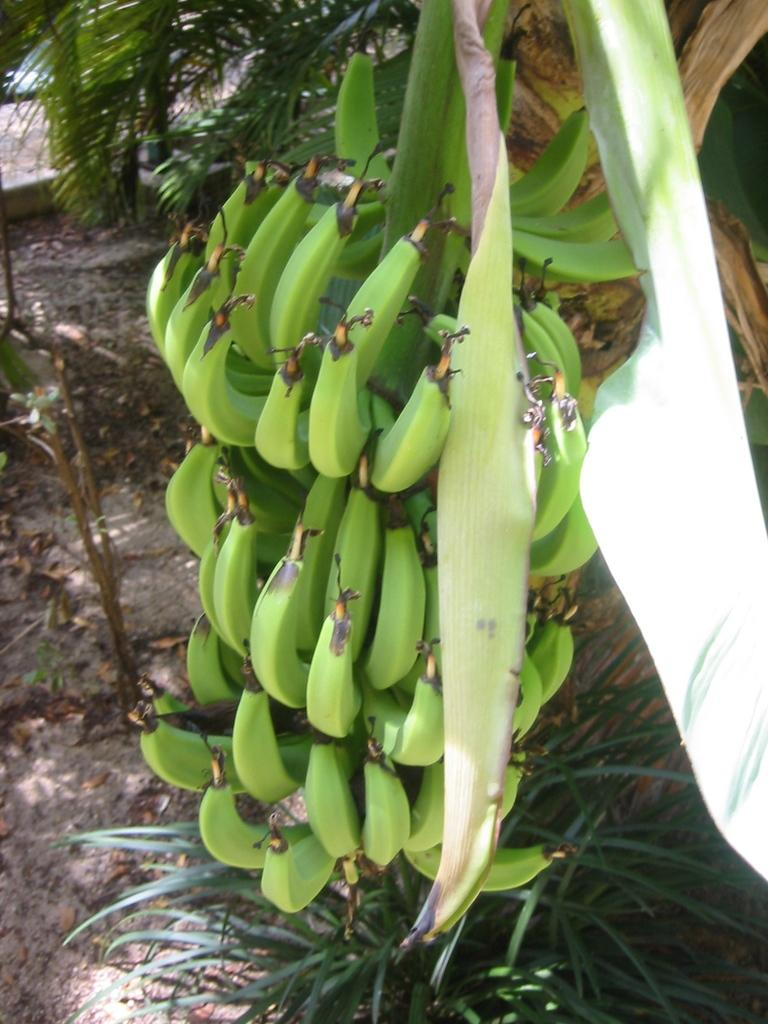What is the main subject of the image? The main subject of the image is bananas. Where are the bananas located in the image? The bananas are in the center of the image. Is the quicksand visible in the image? There is no quicksand present in the image; it features bananas in the center. What type of sticks can be seen in the image? There are no sticks visible in the image, as it only features bananas. 